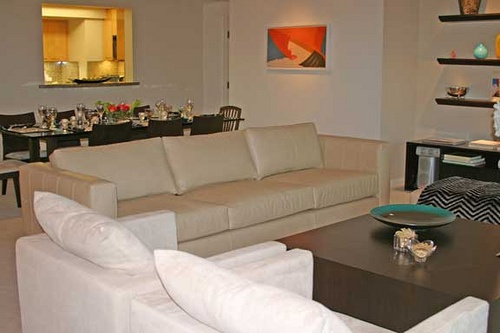Describe the objects in this image and their specific colors. I can see couch in gray, lightgray, and darkgray tones, couch in gray and tan tones, dining table in gray, black, and tan tones, bowl in gray, teal, and black tones, and chair in gray and black tones in this image. 